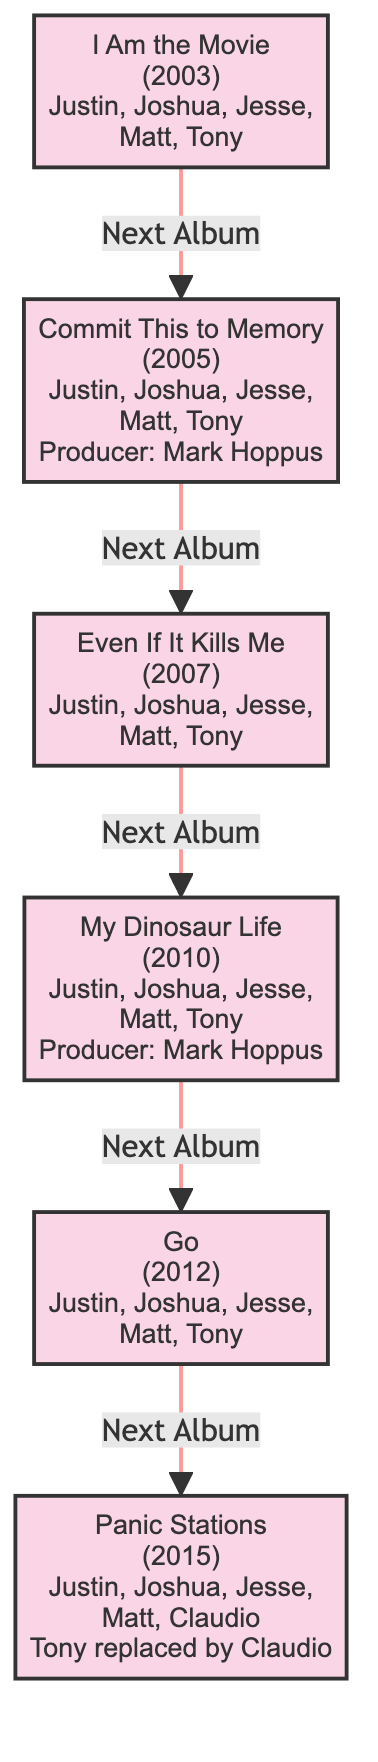What is the first album listed in the diagram? The first block in the diagram is labeled "I Am the Movie," which is the first album released by Motion City Soundtrack in 2003.
Answer: I Am the Movie How many albums are represented in the diagram? There are a total of six blocks representing different albums in the diagram, indicating the band's discography over the years.
Answer: 6 What year was "My Dinosaur Life" released? The block for "My Dinosaur Life" shows that it was released in 2010, making it one of the band's later albums.
Answer: 2010 Who produced "Commit This to Memory"? The block depicting "Commit This to Memory" states that Mark Hoppus was the producer for this album, which adds notable context about its production.
Answer: Mark Hoppus What notable member change occurred between "Go" and "Panic Stations"? "Panic Stations" indicates a change where Tony Thaxton was replaced by Claudio Rivera as a band member, reflecting an evolution in the band's lineup.
Answer: Tony replaced by Claudio Which album comes after "Even If It Kills Me"? Following the directional arrows in the diagram, "My Dinosaur Life" is the album that comes next after "Even If It Kills Me," showing the chronological progression of their releases.
Answer: My Dinosaur Life Which members were present in the band for all albums except "Panic Stations"? By reviewing the member lists in the blocks, it is confirmed that Justin Pierre, Joshua Cain, Jesse Johnson, Matt Taylor were in every album except for "Panic Stations," where Claudio Rivera joined.
Answer: Justin, Joshua, Jesse, Matt What is the relationship between "I Am the Movie" and "Commit This to Memory"? The diagram illustrates a "Next Album" relationship pointing from "I Am the Movie" to "Commit This to Memory," showing the sequential order of album releases.
Answer: Next Album 